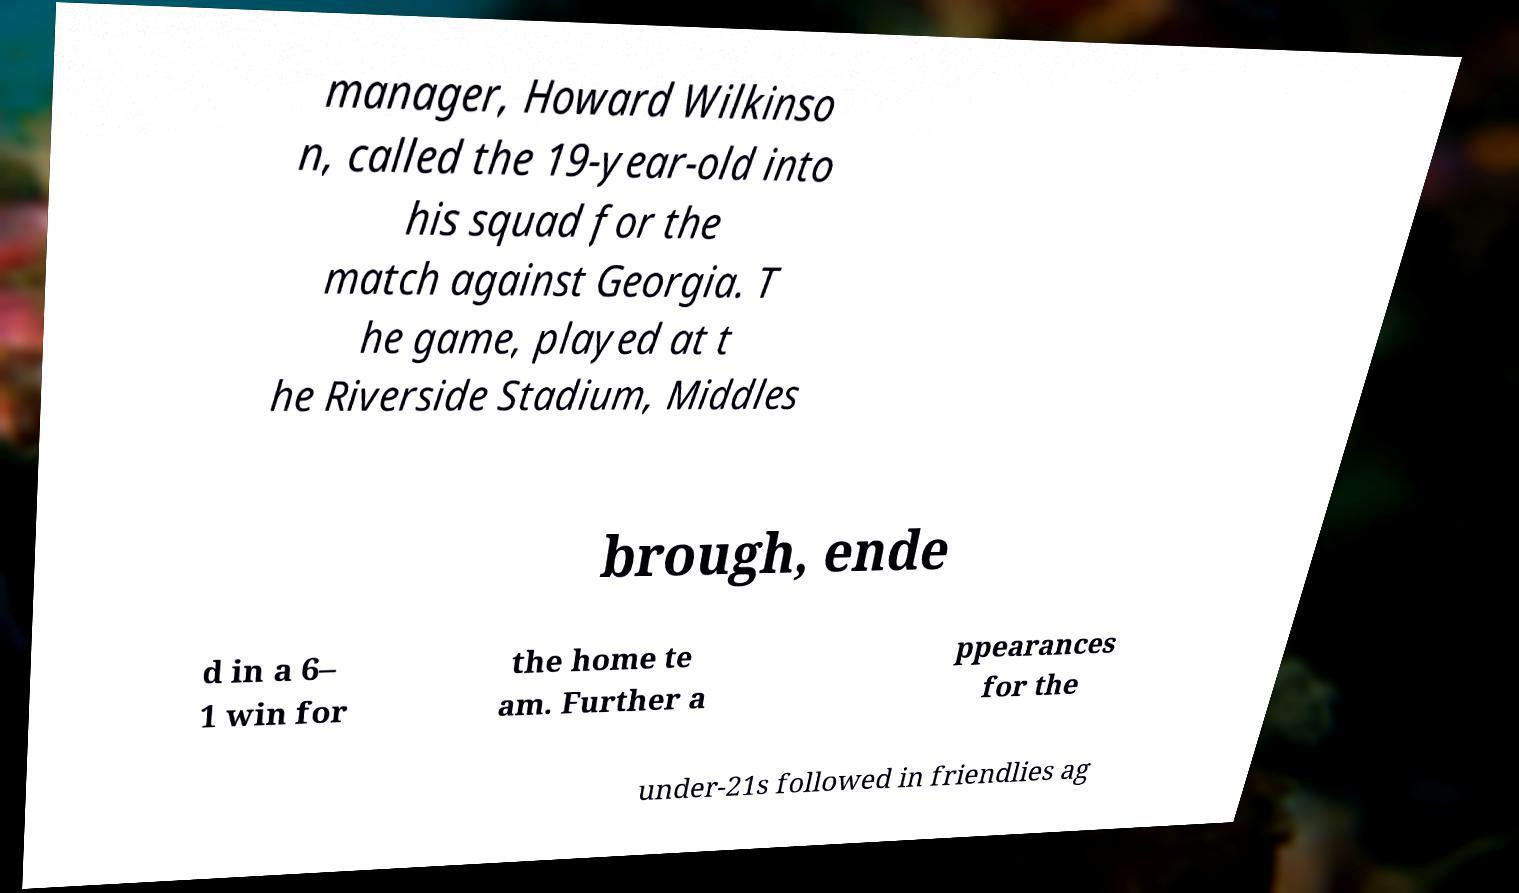There's text embedded in this image that I need extracted. Can you transcribe it verbatim? manager, Howard Wilkinso n, called the 19-year-old into his squad for the match against Georgia. T he game, played at t he Riverside Stadium, Middles brough, ende d in a 6– 1 win for the home te am. Further a ppearances for the under-21s followed in friendlies ag 